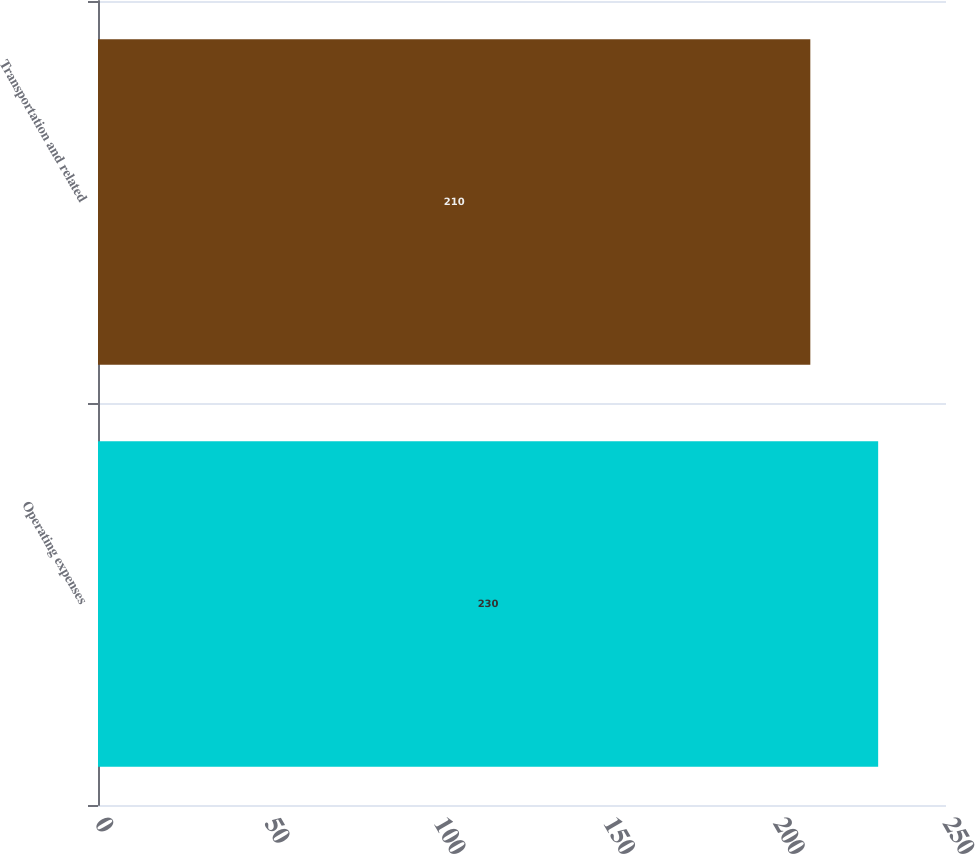Convert chart. <chart><loc_0><loc_0><loc_500><loc_500><bar_chart><fcel>Operating expenses<fcel>Transportation and related<nl><fcel>230<fcel>210<nl></chart> 